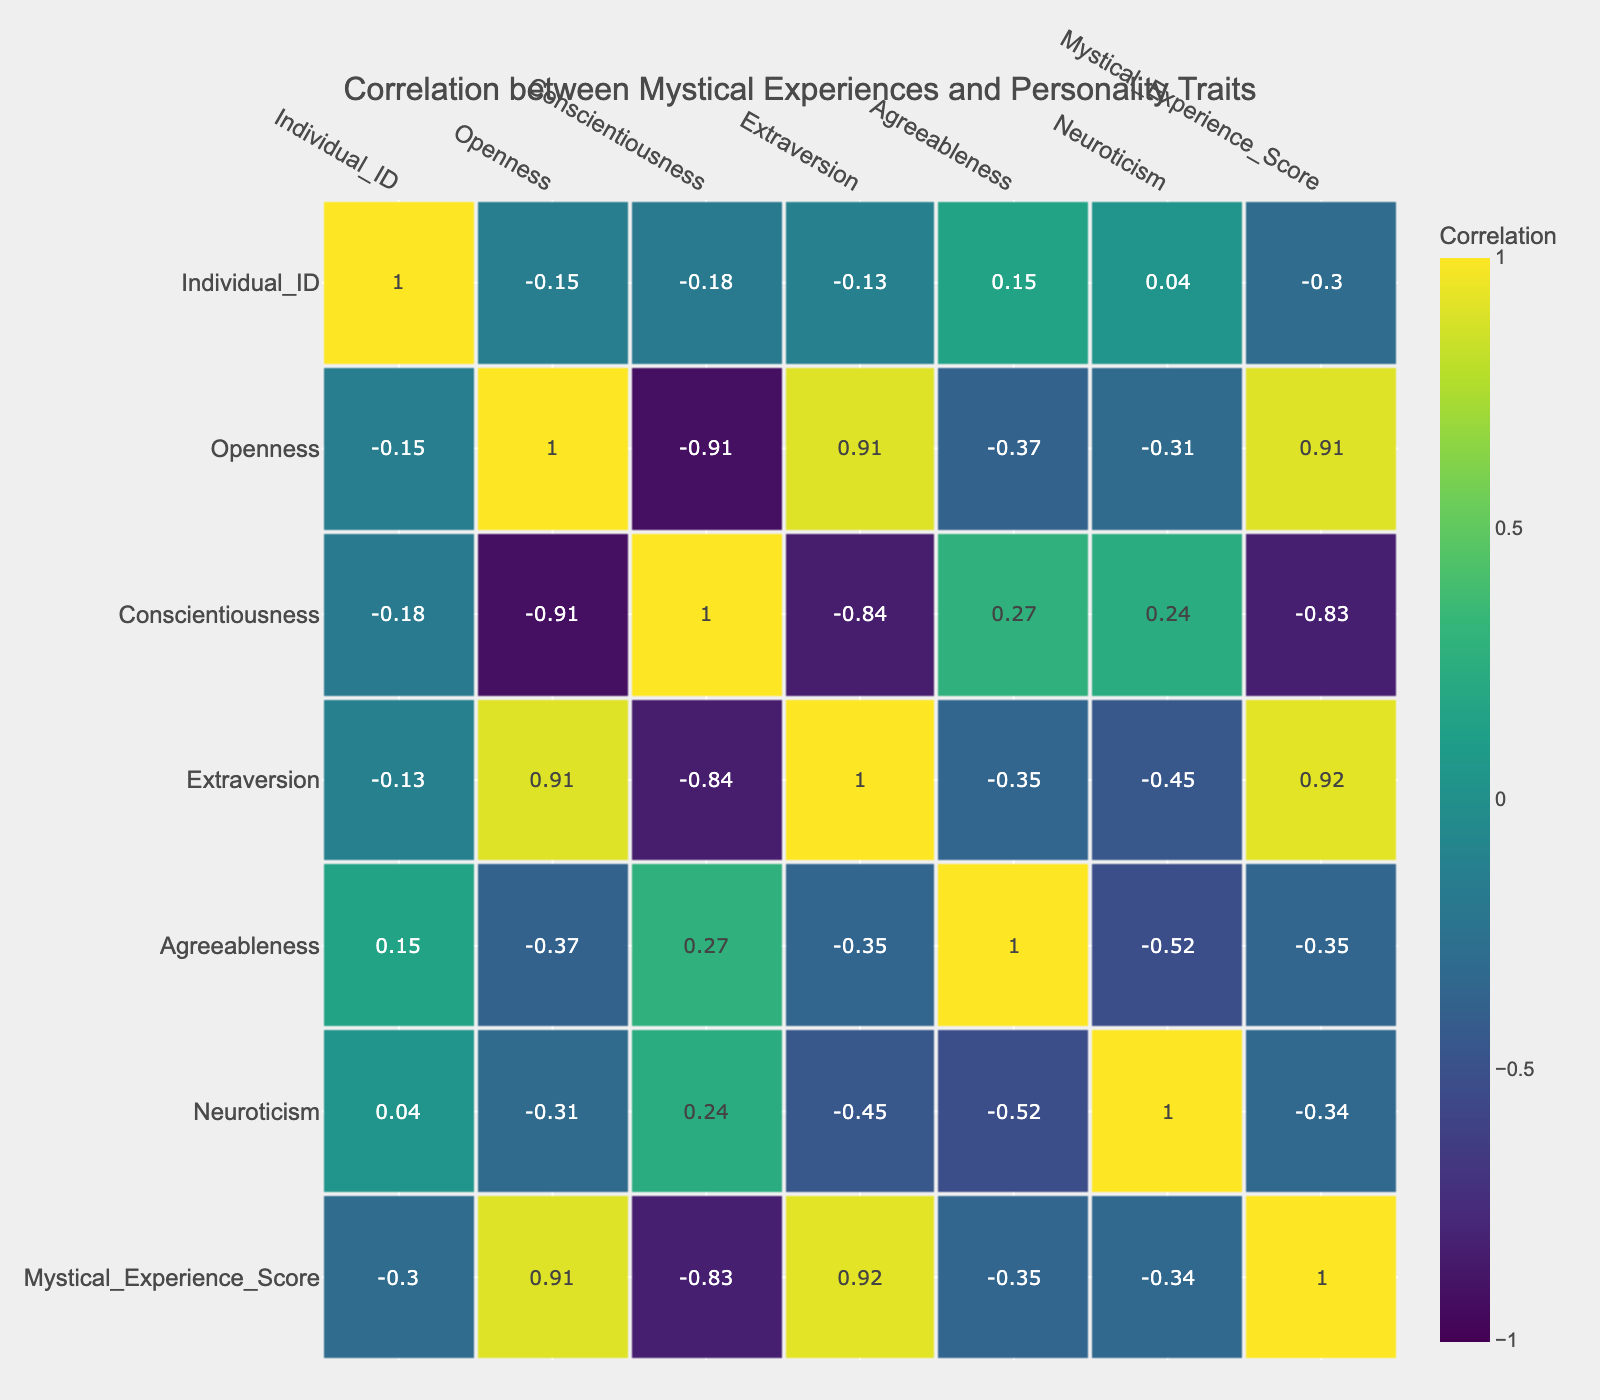What is the correlation coefficient between Openness and Mystical Experience Score? To find the correlation coefficient between Openness and Mystical Experience Score, we look at the table which shows the values. The correlation between Openness and Mystical Experience Score is 0.77.
Answer: 0.77 Which individual has the highest score in Mystical Experience? By reviewing the Mystical Experience Score column, the individual with the highest score is Individual ID 8, who has a score of 10.
Answer: Individual ID 8 What is the average score of Mystical Experiences for individuals with high Agreeableness (consider scores above 0.8)? We identify individuals with Agreeableness greater than 0.8 which are Individual ID 3, 4, 5, and 8. Their scores are 7, 6, 8, and 10. Their average is (7 + 6 + 8 + 10) / 4 = 7.75.
Answer: 7.75 Is there a negative correlation between Neuroticism and Mystical Experience Score? By checking the correlation coefficient in the table, the value is -0.34, indicating a slight negative correlation between Neuroticism and Mystical Experience Score. Therefore, yes, there is a negative correlation.
Answer: Yes Which personality trait has the strongest positive correlation with Mystical Experience Score? Looking at the correlation values, Openness has the highest positive correlation at 0.77 with Mystical Experience Score.
Answer: Openness What is the difference in the average score of Mystical Experiences between individuals with low (under 0.6) versus high (above 0.8) levels of Conscientiousness? For low Conscientiousness (Individual ID 6, 7, 8, and 9), their scores are 9, 5, 10, and 4 leading to an average of (9 + 5 + 10 + 4) / 4 = 7. Therefore, for high Conscientiousness (Individuals ID 1, 2, 3, 4, and 5), their scores are 8, 9, 7, 6, and 8 leading to an average of (8 + 9 + 7 + 6 + 8) / 5 = 7.6. The difference is 7.6 - 7 = 0.6.
Answer: 0.6 Do individuals with high Extraversion (above 0.7) all have higher Mystic Experience Scores than those below 0.7? Looking at the two groups, Individuals ID 1, 2, 5, 6, and 8 are above 0.7 with scores 8, 9, 8, 9, and 10. Individuals below 0.7 are ID 3, 4, 7, 9, and 10 with scores 7, 6, 5, 4, and 7. The lowest score in high Extraversion (8) is higher than the highest score in low Extraversion (7). So, yes, individuals with high Extraversion all have higher scores.
Answer: Yes What is the correlation coefficient between Conscientiousness and Agreeableness? In checking the table, the correlation coefficient between Conscientiousness and Agreeableness is found to be 0.65.
Answer: 0.65 